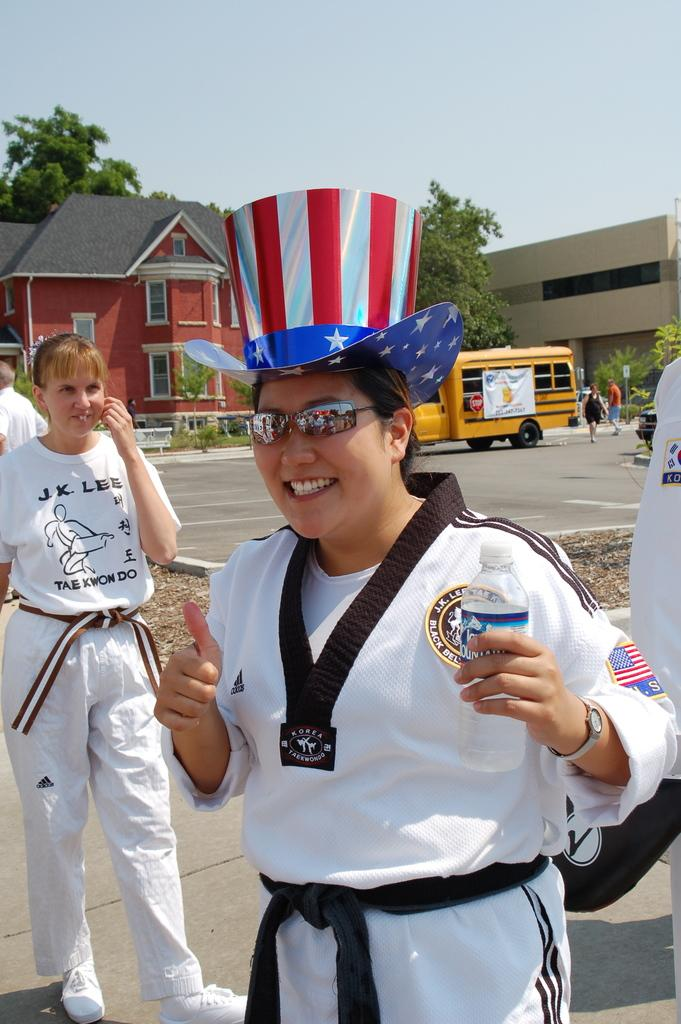Provide a one-sentence caption for the provided image. A woman wearing a patriotic hat wears a black belt with Korea Taekwondo written on it. 